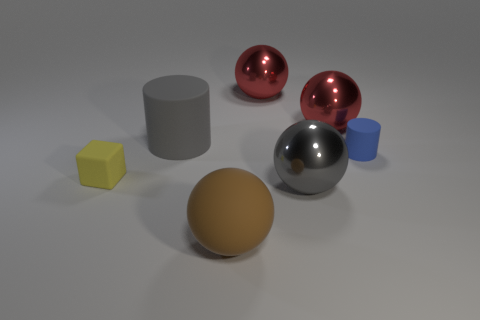Subtract 1 balls. How many balls are left? 3 Add 3 big blue metallic blocks. How many objects exist? 10 Subtract all cylinders. How many objects are left? 5 Add 4 gray metallic spheres. How many gray metallic spheres are left? 5 Add 5 small blue cylinders. How many small blue cylinders exist? 6 Subtract 0 red cylinders. How many objects are left? 7 Subtract all gray metallic things. Subtract all red metallic objects. How many objects are left? 4 